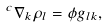Convert formula to latex. <formula><loc_0><loc_0><loc_500><loc_500>{ } ^ { c } \nabla _ { k } \rho _ { l } = \phi g _ { l k } ,</formula> 